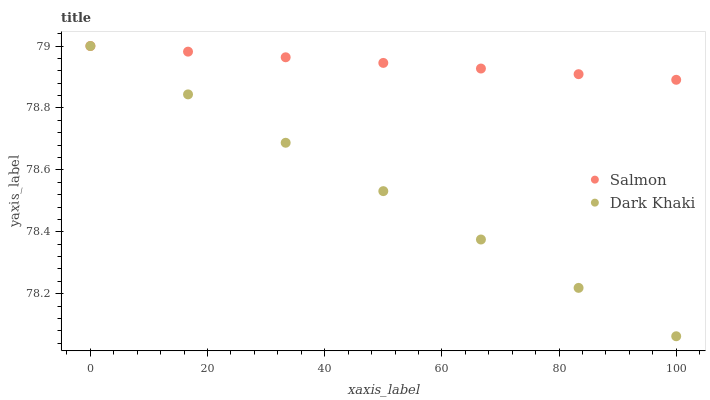Does Dark Khaki have the minimum area under the curve?
Answer yes or no. Yes. Does Salmon have the maximum area under the curve?
Answer yes or no. Yes. Does Salmon have the minimum area under the curve?
Answer yes or no. No. Is Dark Khaki the smoothest?
Answer yes or no. Yes. Is Salmon the roughest?
Answer yes or no. Yes. Is Salmon the smoothest?
Answer yes or no. No. Does Dark Khaki have the lowest value?
Answer yes or no. Yes. Does Salmon have the lowest value?
Answer yes or no. No. Does Salmon have the highest value?
Answer yes or no. Yes. Does Dark Khaki intersect Salmon?
Answer yes or no. Yes. Is Dark Khaki less than Salmon?
Answer yes or no. No. Is Dark Khaki greater than Salmon?
Answer yes or no. No. 